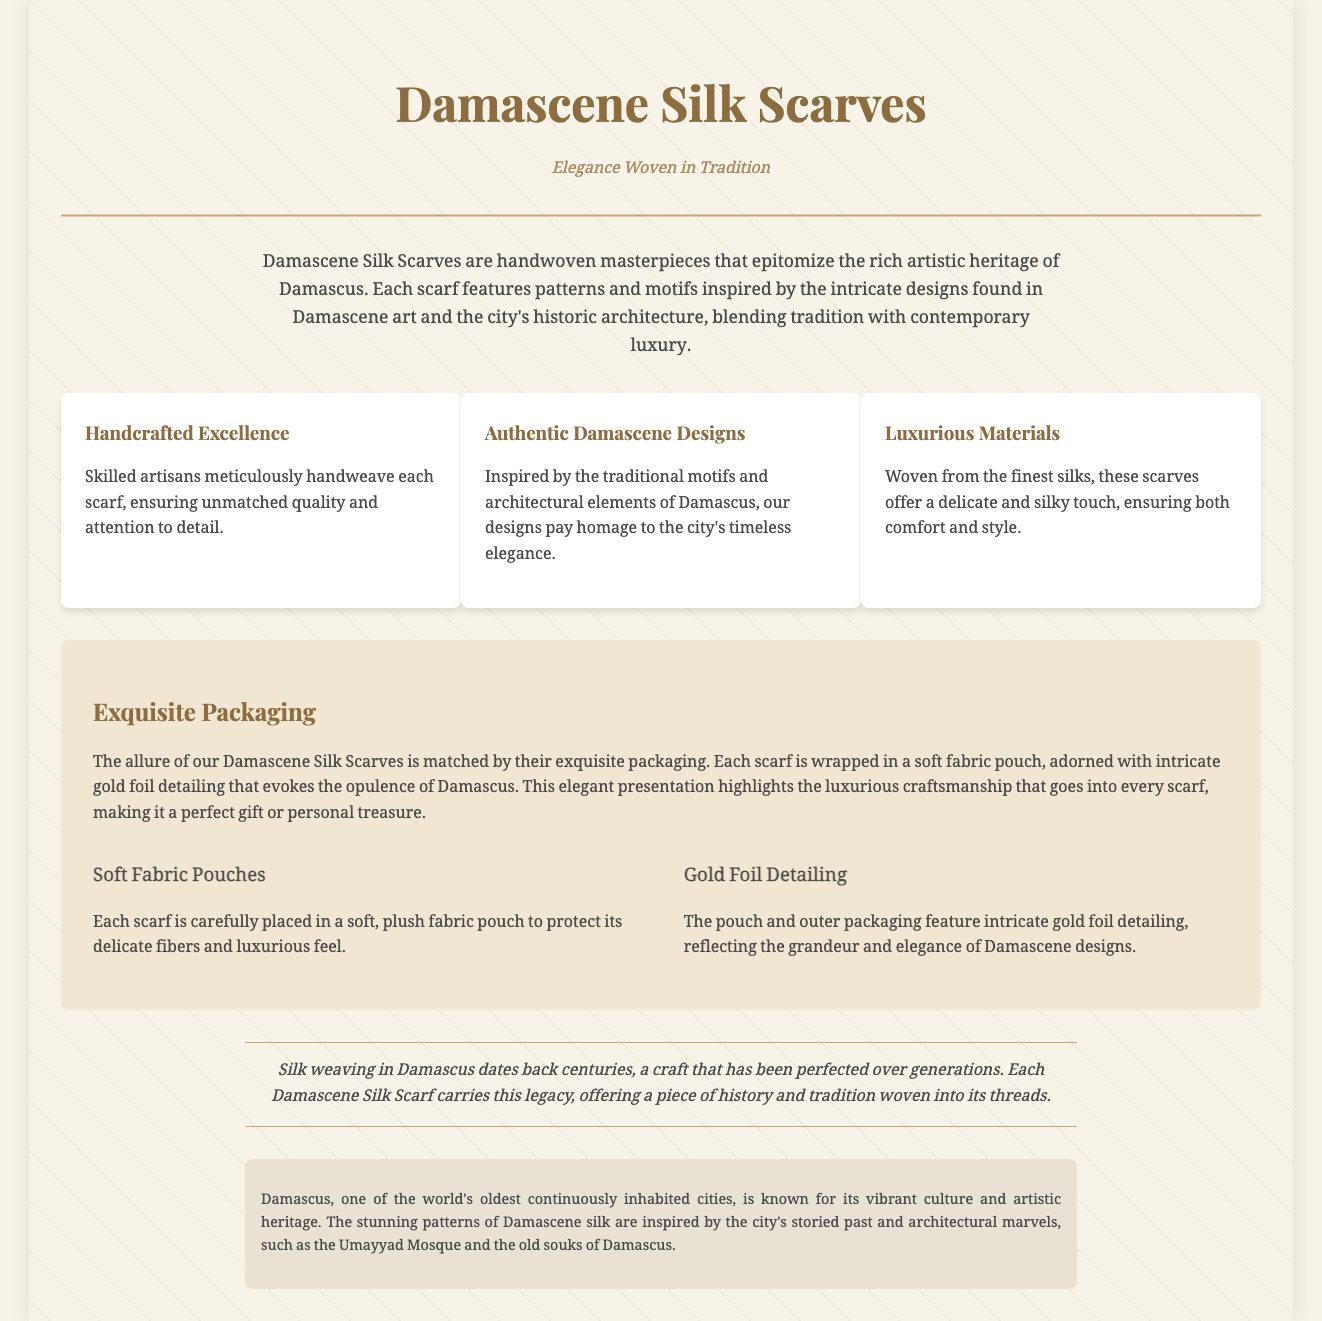What are Damascene Silk Scarves? The document describes them as handwoven masterpieces that epitomize the rich artistic heritage of Damascus.
Answer: Handwoven masterpieces What do the scarves feature? The document states that each scarf features patterns and motifs inspired by Damascene art and architecture.
Answer: Patterns and motifs What are the materials used for the scarves? The document mentions that the scarves are woven from the finest silks.
Answer: Finest silks What type of packaging is used for the scarves? It states that each scarf is wrapped in a soft fabric pouch.
Answer: Soft fabric pouch What does the gold foil detailing evoke? The document explains that it evokes the opulence of Damascus.
Answer: Opulence of Damascus How many features are highlighted in the document? The document lists three features of the scarves.
Answer: Three features What does the heritage section mention about silk weaving in Damascus? It mentions that silk weaving dates back centuries and has been perfected over generations.
Answer: Dates back centuries What is the city known for besides silk? The historical context notes that Damascus is known for its vibrant culture and artistic heritage.
Answer: Vibrant culture What architectural marvel is mentioned in relation to the designs? The Umayyad Mosque is highlighted as an architectural marvel inspiring the designs.
Answer: Umayyad Mosque 